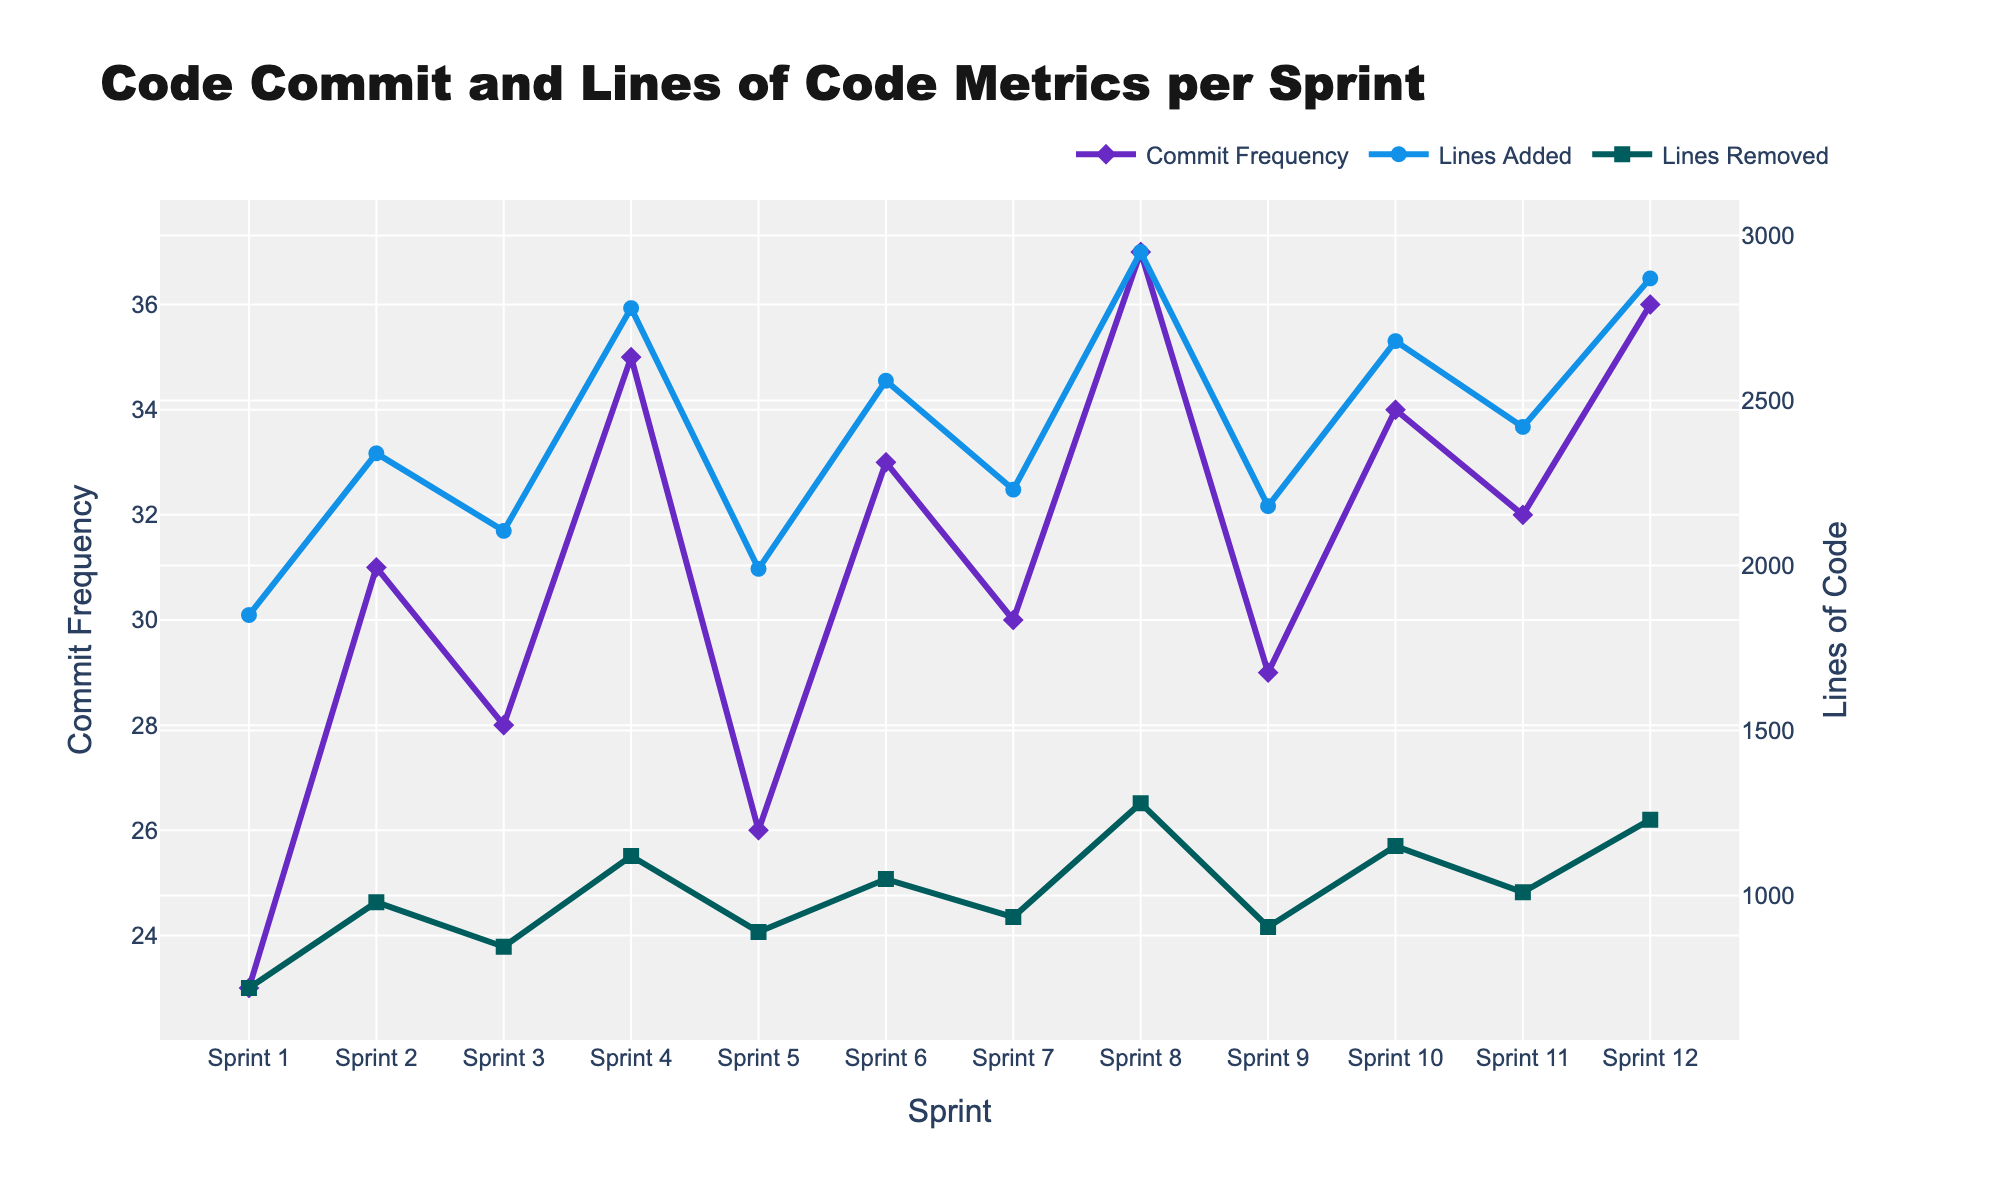What's the sprint with the highest commit frequency? The highest point for the "Commit Frequency" line is at Sprint 8.
Answer: Sprint 8 Which sprint has the maximum lines of code added? The highest point for the "Lines Added" line is also at Sprint 8.
Answer: Sprint 8 How many lines of code were removed in Sprint 5? By looking at the value of the "Lines Removed" line at Sprint 5, it is 890.
Answer: 890 Compare the lines of code added and removed in Sprint 7. Which is higher? In Sprint 7, "Lines Added" is 2230 and "Lines Removed" is 935. 2230 is greater.
Answer: Lines Added What is the total lines of code added and removed in Sprint 6? Lines Added in Sprint 6 is 2560 and Lines Removed is 1050. Summing them up gives 2560 + 1050 = 3610.
Answer: 3610 During which sprint was the difference between lines added and lines removed the smallest? Calculate the difference for each sprint and find the smallest: Sprint 1 (1850 - 720 = 1130), Sprint 2 (2340 - 980 = 1360), Sprint 3 (2105 - 845 = 1260), Sprint 4 (2780 - 1120 = 1660), Sprint 5 (1990 - 890 = 1100), Sprint 6 (2560 - 1050 = 1510), Sprint 7 (2230 - 935 = 1295), Sprint 8 (2950 - 1280 = 1670), Sprint 9 (2180 - 905 = 1275), Sprint 10 (2680 - 1150 = 1530), Sprint 11 (2420 - 1010 = 1410), Sprint 12 (2870 - 1230 = 1640). Sprint 5 has the smallest difference of 1100.
Answer: Sprint 5 Compare commit frequency in Sprint 2 and Sprint 10. Which sprint had a higher frequency? Commit Frequency in Sprint 2 is 31 and in Sprint 10 is 34. Sprint 10 had a higher frequency.
Answer: Sprint 10 What is the average commit frequency over all sprints? Sum all Commit Frequencies: 23 + 31 + 28 + 35 + 26 + 33 + 30 + 37 + 29 + 34 + 32 + 36 = 374. Divide by the number of sprints, 374 / 12 = 31.17
Answer: 31.17 In which sprint did the Lines Removed exceed 1200? Observing the "Lines Removed" line, the values exceed 1200 only at Sprint 8 and Sprint 12.
Answer: Sprint 8 and Sprint 12 What's the visual mark used for commit frequency? The markers on the "Commit Frequency" line are diamond-shaped.
Answer: Diamond 